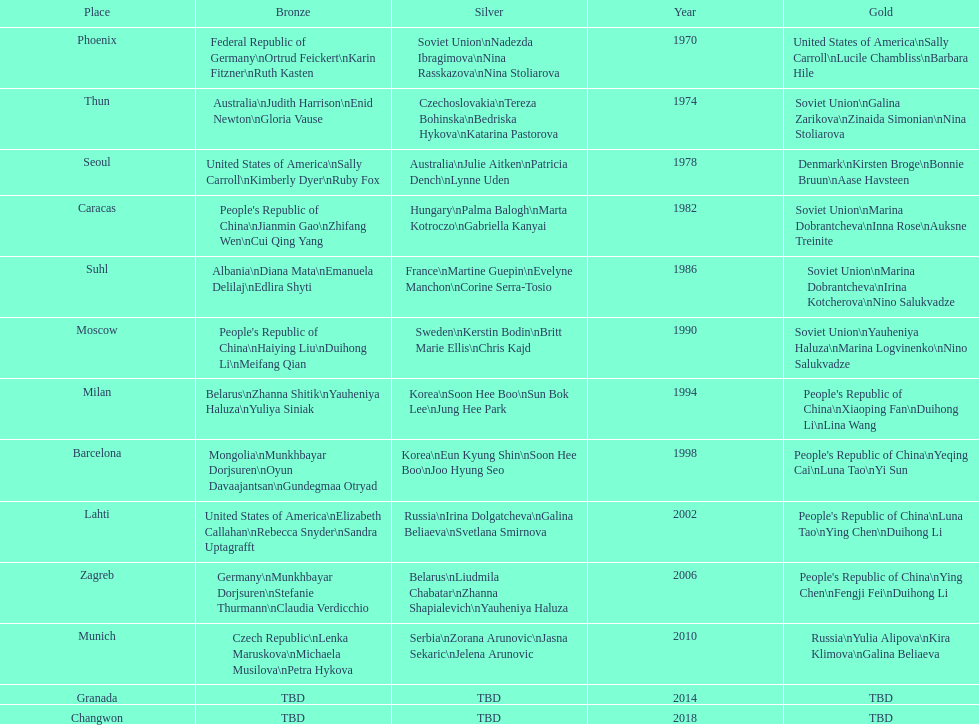Would you mind parsing the complete table? {'header': ['Place', 'Bronze', 'Silver', 'Year', 'Gold'], 'rows': [['Phoenix', 'Federal Republic of Germany\\nOrtrud Feickert\\nKarin Fitzner\\nRuth Kasten', 'Soviet Union\\nNadezda Ibragimova\\nNina Rasskazova\\nNina Stoliarova', '1970', 'United States of America\\nSally Carroll\\nLucile Chambliss\\nBarbara Hile'], ['Thun', 'Australia\\nJudith Harrison\\nEnid Newton\\nGloria Vause', 'Czechoslovakia\\nTereza Bohinska\\nBedriska Hykova\\nKatarina Pastorova', '1974', 'Soviet Union\\nGalina Zarikova\\nZinaida Simonian\\nNina Stoliarova'], ['Seoul', 'United States of America\\nSally Carroll\\nKimberly Dyer\\nRuby Fox', 'Australia\\nJulie Aitken\\nPatricia Dench\\nLynne Uden', '1978', 'Denmark\\nKirsten Broge\\nBonnie Bruun\\nAase Havsteen'], ['Caracas', "People's Republic of China\\nJianmin Gao\\nZhifang Wen\\nCui Qing Yang", 'Hungary\\nPalma Balogh\\nMarta Kotroczo\\nGabriella Kanyai', '1982', 'Soviet Union\\nMarina Dobrantcheva\\nInna Rose\\nAuksne Treinite'], ['Suhl', 'Albania\\nDiana Mata\\nEmanuela Delilaj\\nEdlira Shyti', 'France\\nMartine Guepin\\nEvelyne Manchon\\nCorine Serra-Tosio', '1986', 'Soviet Union\\nMarina Dobrantcheva\\nIrina Kotcherova\\nNino Salukvadze'], ['Moscow', "People's Republic of China\\nHaiying Liu\\nDuihong Li\\nMeifang Qian", 'Sweden\\nKerstin Bodin\\nBritt Marie Ellis\\nChris Kajd', '1990', 'Soviet Union\\nYauheniya Haluza\\nMarina Logvinenko\\nNino Salukvadze'], ['Milan', 'Belarus\\nZhanna Shitik\\nYauheniya Haluza\\nYuliya Siniak', 'Korea\\nSoon Hee Boo\\nSun Bok Lee\\nJung Hee Park', '1994', "People's Republic of China\\nXiaoping Fan\\nDuihong Li\\nLina Wang"], ['Barcelona', 'Mongolia\\nMunkhbayar Dorjsuren\\nOyun Davaajantsan\\nGundegmaa Otryad', 'Korea\\nEun Kyung Shin\\nSoon Hee Boo\\nJoo Hyung Seo', '1998', "People's Republic of China\\nYeqing Cai\\nLuna Tao\\nYi Sun"], ['Lahti', 'United States of America\\nElizabeth Callahan\\nRebecca Snyder\\nSandra Uptagrafft', 'Russia\\nIrina Dolgatcheva\\nGalina Beliaeva\\nSvetlana Smirnova', '2002', "People's Republic of China\\nLuna Tao\\nYing Chen\\nDuihong Li"], ['Zagreb', 'Germany\\nMunkhbayar Dorjsuren\\nStefanie Thurmann\\nClaudia Verdicchio', 'Belarus\\nLiudmila Chabatar\\nZhanna Shapialevich\\nYauheniya Haluza', '2006', "People's Republic of China\\nYing Chen\\nFengji Fei\\nDuihong Li"], ['Munich', 'Czech Republic\\nLenka Maruskova\\nMichaela Musilova\\nPetra Hykova', 'Serbia\\nZorana Arunovic\\nJasna Sekaric\\nJelena Arunovic', '2010', 'Russia\\nYulia Alipova\\nKira Klimova\\nGalina Beliaeva'], ['Granada', 'TBD', 'TBD', '2014', 'TBD'], ['Changwon', 'TBD', 'TBD', '2018', 'TBD']]} Name one of the top three women to earn gold at the 1970 world championship held in phoenix, az Sally Carroll. 